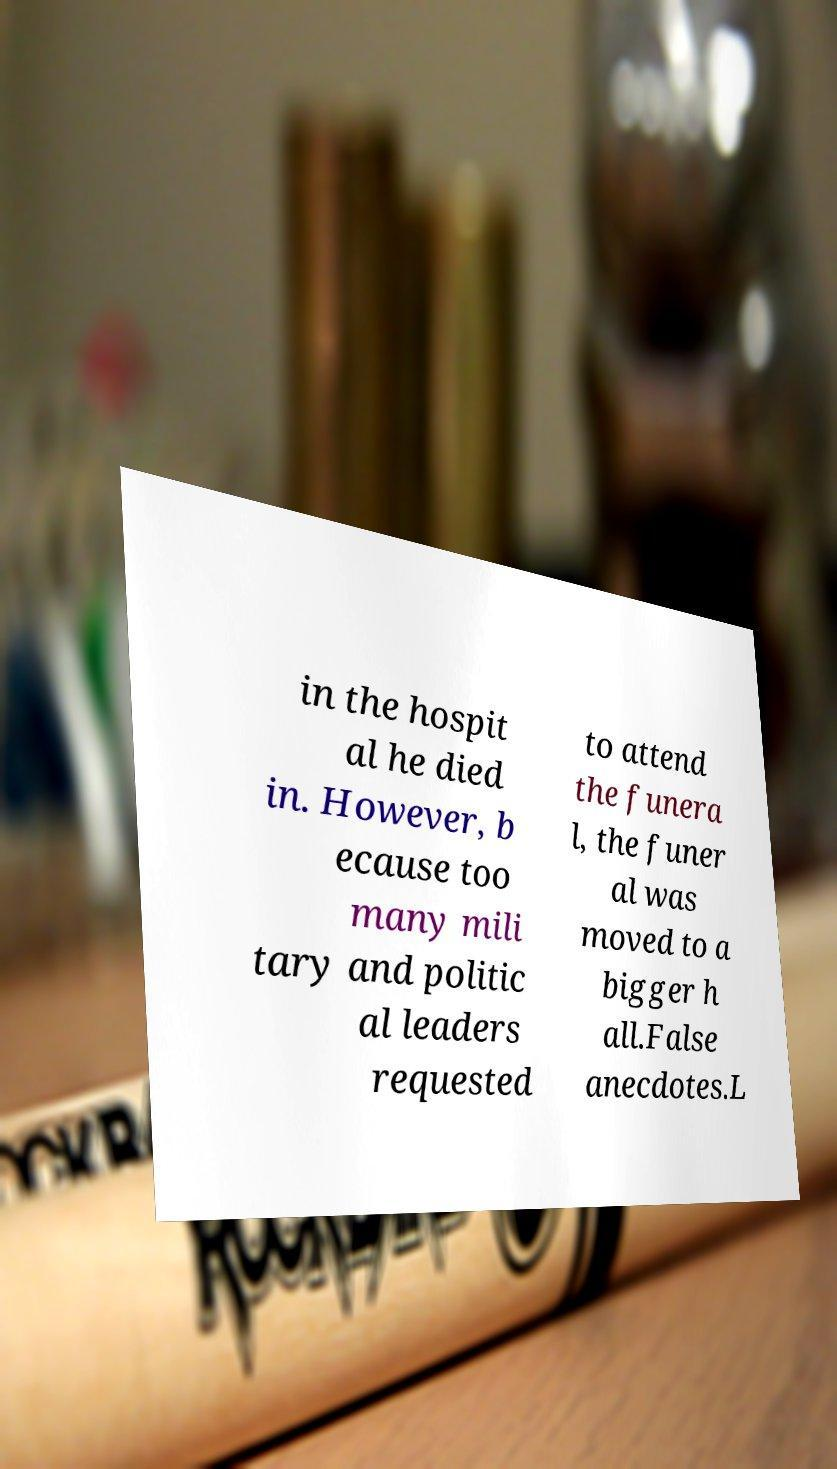Can you read and provide the text displayed in the image?This photo seems to have some interesting text. Can you extract and type it out for me? in the hospit al he died in. However, b ecause too many mili tary and politic al leaders requested to attend the funera l, the funer al was moved to a bigger h all.False anecdotes.L 